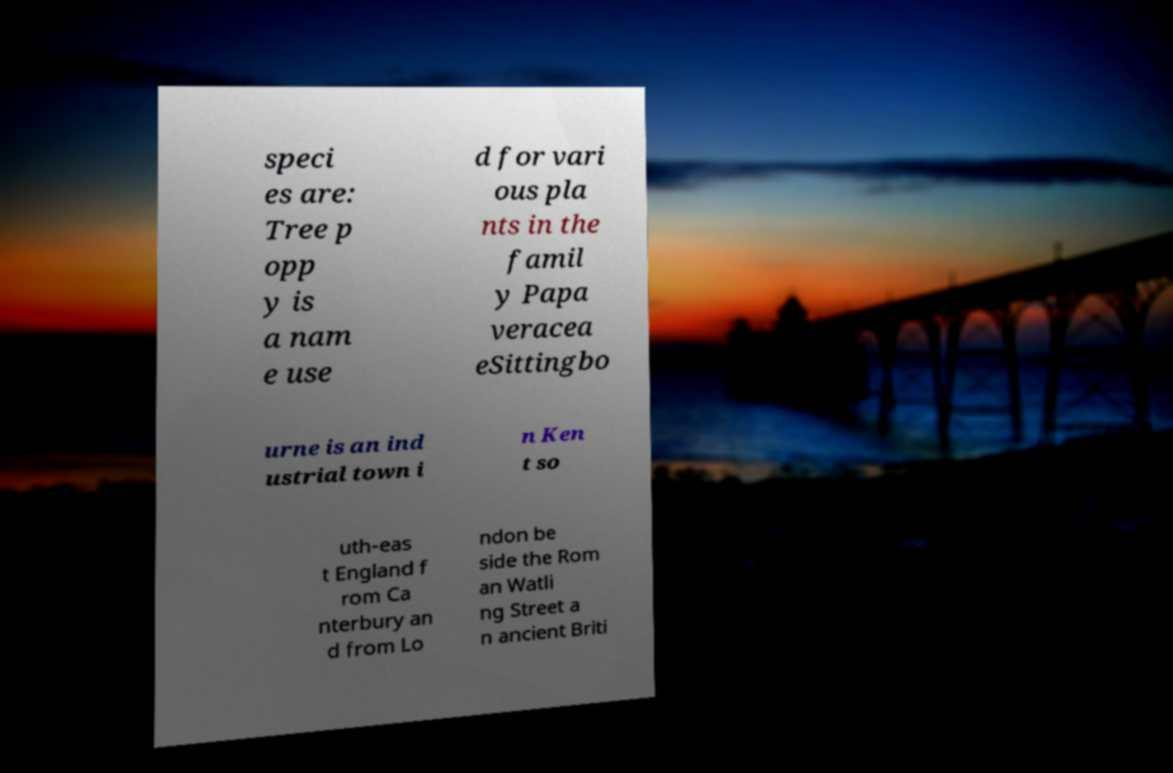For documentation purposes, I need the text within this image transcribed. Could you provide that? speci es are: Tree p opp y is a nam e use d for vari ous pla nts in the famil y Papa veracea eSittingbo urne is an ind ustrial town i n Ken t so uth-eas t England f rom Ca nterbury an d from Lo ndon be side the Rom an Watli ng Street a n ancient Briti 